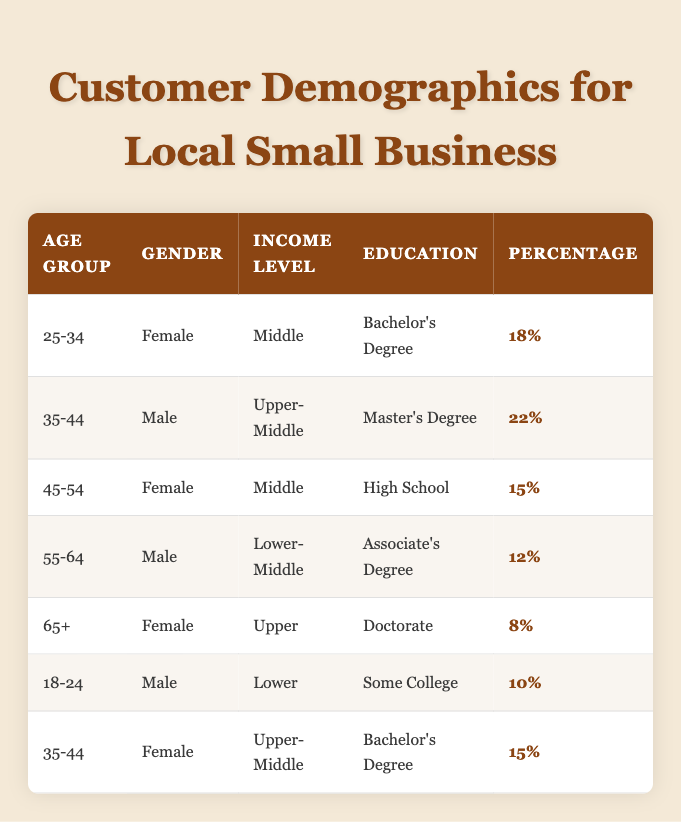What is the percentage of customers aged 25-34 who are female? The table indicates that for the age group 25-34, the percentage of female customers is 18%.
Answer: 18% Which income level has the highest percentage of customers in the table? By reviewing the percentages in each income level category, the upper-middle income level (35-44 Male with 22%) has the highest percentage.
Answer: Upper-Middle Are there any customers aged 65 or older with a bachelor's degree? The data does not list any customers aged 65 or older having a bachelor's degree, as the only age group with 65+ includes one female with a doctorate degree.
Answer: No What is the average percentage of female customers across all age groups? To calculate the average for female customers from the relevant rows, we take the percentages for 25-34 (18%), 45-54 (15%), and 35-44 (15%) giving us (18 + 15 + 15) = 48%. Since there are three data points, we divide by 3, resulting in an average of 16%.
Answer: 16% Is there a higher percentage of upper-middle income customers who are male or female? Looking at the table, the male customer group aged 35-44 has a percentage of 22% as upper-middle income, while the female customer group in the same category has a percentage of 15%. Hence, the percentage is higher for males.
Answer: Male What percentage of total customers listed have an associate's degree? From the table, there is one male aged 55-64 with an associate's degree, accounting for 12% of the total. Therefore, the percentage of customers with an associate's degree is 12%.
Answer: 12% How many total age groups have male customers? Counting the rows, we have male customers in the age groups 18-24, 35-44, and 55-64. Therefore, there are three distinct male age groups.
Answer: 3 If we combine the percentages of all customers aged 35-44, what is the total? For the age group 35-44, the percentages from the table are 22% (male) and 15% (female), when combined: 22 + 15 = 37%. Hence, the total is 37%.
Answer: 37% Which gender appears more frequently in the age group 45-54? The table shows that in the 45-54 age group, the only associated gender is female. Hence, female appears more frequently in this age group.
Answer: Female Which age group has the lowest percentage of customers with a doctorate? The 65+ age group has the lowest percentage with 8% for customers having a doctorate (the only such case listed in the table).
Answer: 65+ 